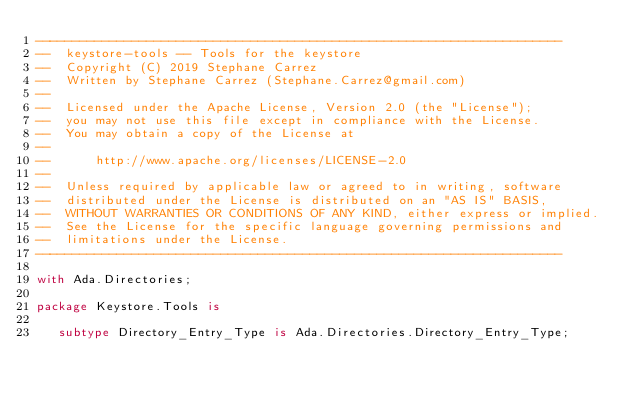Convert code to text. <code><loc_0><loc_0><loc_500><loc_500><_Ada_>-----------------------------------------------------------------------
--  keystore-tools -- Tools for the keystore
--  Copyright (C) 2019 Stephane Carrez
--  Written by Stephane Carrez (Stephane.Carrez@gmail.com)
--
--  Licensed under the Apache License, Version 2.0 (the "License");
--  you may not use this file except in compliance with the License.
--  You may obtain a copy of the License at
--
--      http://www.apache.org/licenses/LICENSE-2.0
--
--  Unless required by applicable law or agreed to in writing, software
--  distributed under the License is distributed on an "AS IS" BASIS,
--  WITHOUT WARRANTIES OR CONDITIONS OF ANY KIND, either express or implied.
--  See the License for the specific language governing permissions and
--  limitations under the License.
-----------------------------------------------------------------------

with Ada.Directories;

package Keystore.Tools is

   subtype Directory_Entry_Type is Ada.Directories.Directory_Entry_Type;
</code> 